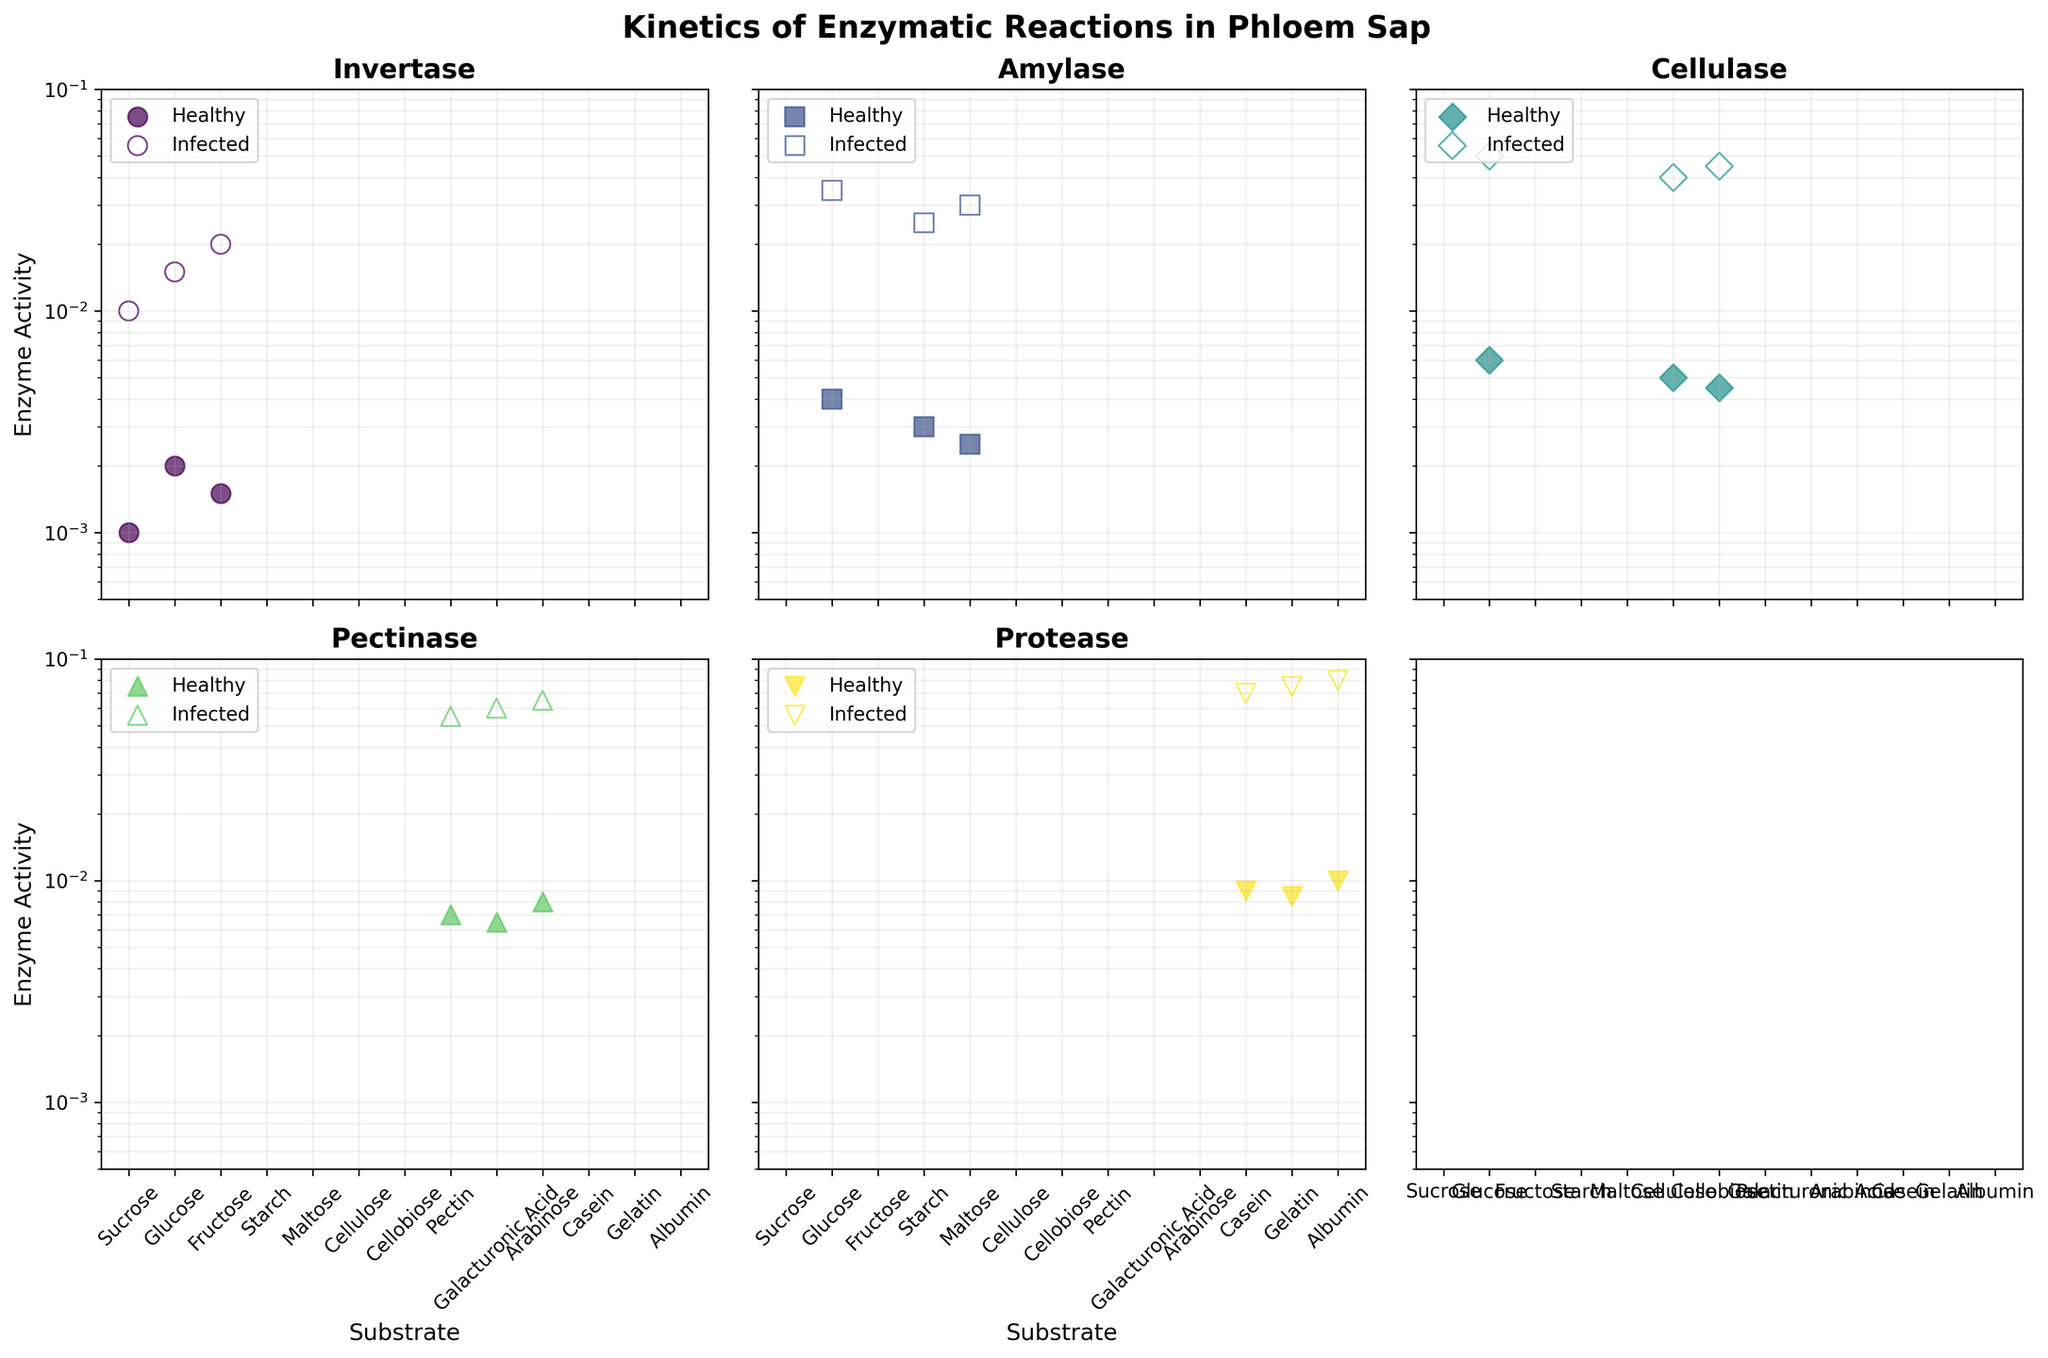How many enzymes are analyzed in the figure? There are multiple subplots with different enzyme names; counting these will give the number of enzymes analyzed.
Answer: 5 Which enzyme shows the highest activity for Sucrose in infected conditions? Looking at the subplot for Invertase, compare the activity levels for healthy and infected conditions. The infected condition shows the highest activity for Sucrose.
Answer: Invertase Are there any substrates that show higher enzyme activity in healthy conditions compared to infected ones? By comparing each subplot, observe the enzyme activities for both conditions. In all the subplots, the infected conditions have higher enzyme activity compared to healthy conditions, so the answer is no.
Answer: No What's the difference in enzyme activity between healthy and infected conditions for Glucose with Cellulase? In the subplot for Cellulase, find the enzyme activity for Glucose. The difference is 0.05 - 0.006.
Answer: 0.044 Which enzyme has the highest increase in activity from healthy to infected conditions for its substrates? Observe the difference in enzyme activities for each enzyme between healthy and infected conditions. Pectinase shows the highest increase as it has the greatest difference.
Answer: Pectinase Which enzyme and substrate combination shows the smallest change in enzyme activity between healthy and infected conditions? Compare the changes for each enzyme-substrate pair across the subplots. The smallest change is seen with Invertase for Sucrose.
Answer: Invertase, Sucrose Is the enzyme activity for Amylase with Maltose in healthy conditions greater than the activity of Invertase with Glucose in the same condition? Look at the subplots for Amylase and Invertase and compare the healthy condition activities for Maltose and Glucose. Amylase (0.0025) is greater than Invertase (0.002).
Answer: Yes Which enzyme shows the highest activity for Cellulose under infected conditions? In the subplot for Cellulase, locate the activity for Cellulose. The higher activity under infected conditions is 0.04.
Answer: Cellulase How is the y-axis scaled in the subplots? Look at the scale of the y-axis. The presence of a log scale wrinkles the spacing between numerical values.
Answer: Log scale Are healthy or infected conditions generally associated with larger enzyme activities? By comparing all the enzyme activity dots within subplots, infected conditions generally have larger enzyme activities than healthy conditions.
Answer: Infected conditions 